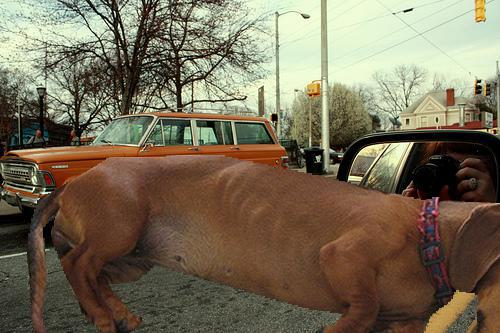Is there anything unusual or unexpected in this scene? Yes, there is a large dog in the foreground with a somewhat disproportionate body that could be confused with other animals due to its unique appearance and size. Could the dog's appearance possibly be the result of a digital manipulation or an unusual camera angle? It's possible that the dog's unusual appearance is the result of a trick of perspective or digital editing, as it seems disproportionately large and oddly positioned in the frame. 